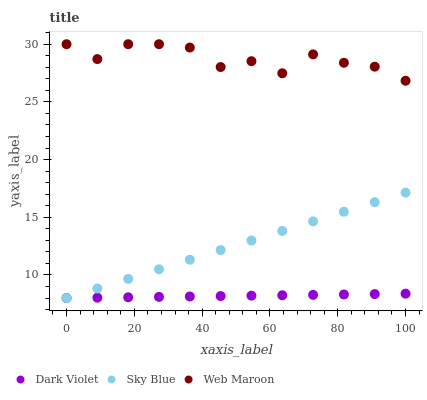Does Dark Violet have the minimum area under the curve?
Answer yes or no. Yes. Does Web Maroon have the maximum area under the curve?
Answer yes or no. Yes. Does Web Maroon have the minimum area under the curve?
Answer yes or no. No. Does Dark Violet have the maximum area under the curve?
Answer yes or no. No. Is Sky Blue the smoothest?
Answer yes or no. Yes. Is Web Maroon the roughest?
Answer yes or no. Yes. Is Dark Violet the smoothest?
Answer yes or no. No. Is Dark Violet the roughest?
Answer yes or no. No. Does Sky Blue have the lowest value?
Answer yes or no. Yes. Does Web Maroon have the lowest value?
Answer yes or no. No. Does Web Maroon have the highest value?
Answer yes or no. Yes. Does Dark Violet have the highest value?
Answer yes or no. No. Is Sky Blue less than Web Maroon?
Answer yes or no. Yes. Is Web Maroon greater than Sky Blue?
Answer yes or no. Yes. Does Dark Violet intersect Sky Blue?
Answer yes or no. Yes. Is Dark Violet less than Sky Blue?
Answer yes or no. No. Is Dark Violet greater than Sky Blue?
Answer yes or no. No. Does Sky Blue intersect Web Maroon?
Answer yes or no. No. 